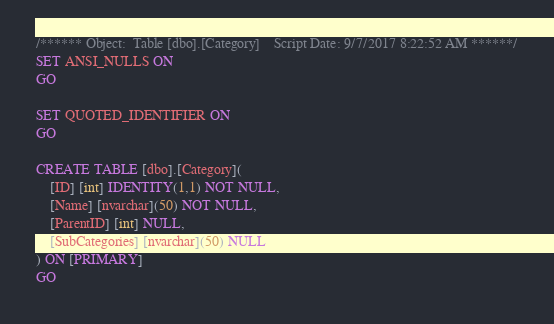Convert code to text. <code><loc_0><loc_0><loc_500><loc_500><_SQL_>/****** Object:  Table [dbo].[Category]    Script Date: 9/7/2017 8:22:52 AM ******/
SET ANSI_NULLS ON
GO

SET QUOTED_IDENTIFIER ON
GO

CREATE TABLE [dbo].[Category](
	[ID] [int] IDENTITY(1,1) NOT NULL,
	[Name] [nvarchar](50) NOT NULL,
	[ParentID] [int] NULL,
	[SubCategories] [nvarchar](50) NULL
) ON [PRIMARY]
GO


</code> 